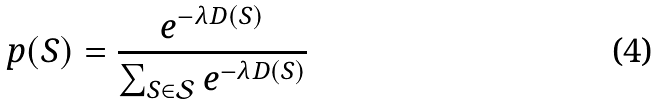Convert formula to latex. <formula><loc_0><loc_0><loc_500><loc_500>p ( S ) = \frac { e ^ { - \lambda D ( S ) } } { \sum _ { S \in \mathcal { S } } { e ^ { - \lambda D ( S ) } } }</formula> 